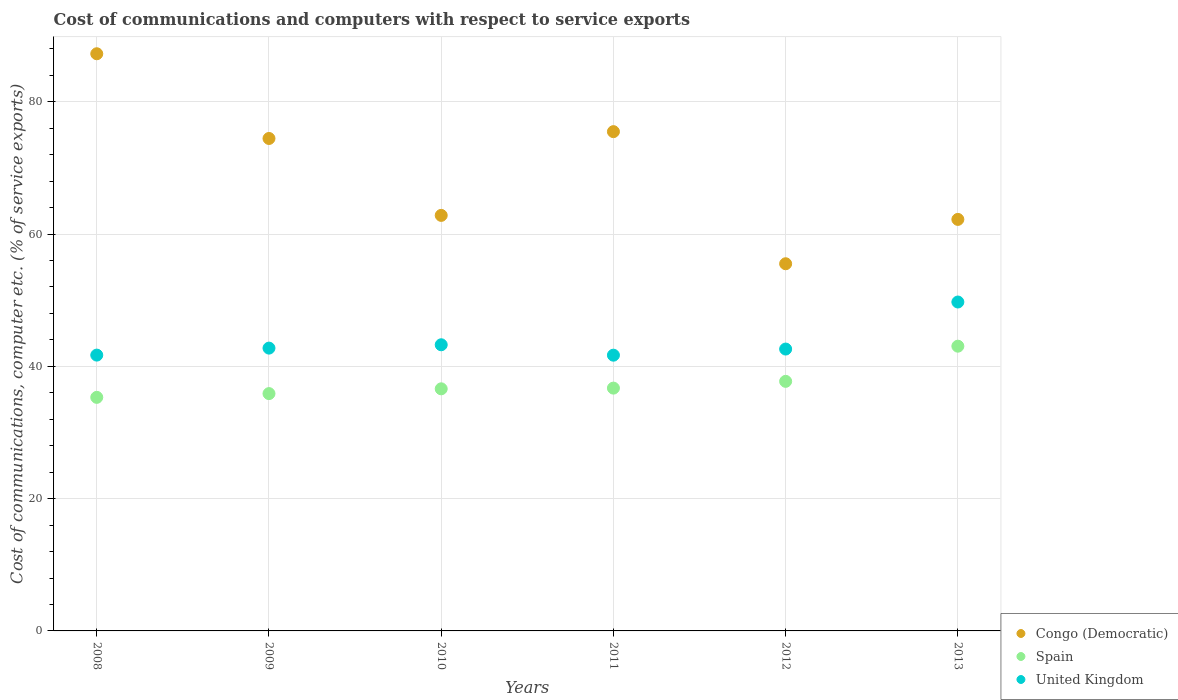How many different coloured dotlines are there?
Offer a very short reply. 3. What is the cost of communications and computers in Congo (Democratic) in 2012?
Give a very brief answer. 55.5. Across all years, what is the maximum cost of communications and computers in United Kingdom?
Make the answer very short. 49.72. Across all years, what is the minimum cost of communications and computers in Congo (Democratic)?
Offer a very short reply. 55.5. In which year was the cost of communications and computers in United Kingdom maximum?
Your response must be concise. 2013. In which year was the cost of communications and computers in Spain minimum?
Your answer should be compact. 2008. What is the total cost of communications and computers in Congo (Democratic) in the graph?
Ensure brevity in your answer.  417.7. What is the difference between the cost of communications and computers in United Kingdom in 2010 and that in 2011?
Your answer should be very brief. 1.57. What is the difference between the cost of communications and computers in Spain in 2011 and the cost of communications and computers in United Kingdom in 2013?
Keep it short and to the point. -13.02. What is the average cost of communications and computers in Congo (Democratic) per year?
Make the answer very short. 69.62. In the year 2012, what is the difference between the cost of communications and computers in United Kingdom and cost of communications and computers in Spain?
Provide a succinct answer. 4.88. In how many years, is the cost of communications and computers in United Kingdom greater than 24 %?
Provide a short and direct response. 6. What is the ratio of the cost of communications and computers in Congo (Democratic) in 2011 to that in 2013?
Provide a succinct answer. 1.21. Is the cost of communications and computers in United Kingdom in 2011 less than that in 2012?
Your answer should be compact. Yes. Is the difference between the cost of communications and computers in United Kingdom in 2008 and 2009 greater than the difference between the cost of communications and computers in Spain in 2008 and 2009?
Make the answer very short. No. What is the difference between the highest and the second highest cost of communications and computers in United Kingdom?
Provide a short and direct response. 6.46. What is the difference between the highest and the lowest cost of communications and computers in United Kingdom?
Provide a short and direct response. 8.04. In how many years, is the cost of communications and computers in United Kingdom greater than the average cost of communications and computers in United Kingdom taken over all years?
Your answer should be compact. 1. Is it the case that in every year, the sum of the cost of communications and computers in United Kingdom and cost of communications and computers in Spain  is greater than the cost of communications and computers in Congo (Democratic)?
Provide a succinct answer. No. Does the cost of communications and computers in United Kingdom monotonically increase over the years?
Keep it short and to the point. No. Is the cost of communications and computers in United Kingdom strictly less than the cost of communications and computers in Spain over the years?
Your response must be concise. No. How many dotlines are there?
Your response must be concise. 3. How many years are there in the graph?
Offer a very short reply. 6. How many legend labels are there?
Keep it short and to the point. 3. What is the title of the graph?
Give a very brief answer. Cost of communications and computers with respect to service exports. What is the label or title of the X-axis?
Ensure brevity in your answer.  Years. What is the label or title of the Y-axis?
Your answer should be very brief. Cost of communications, computer etc. (% of service exports). What is the Cost of communications, computer etc. (% of service exports) in Congo (Democratic) in 2008?
Keep it short and to the point. 87.25. What is the Cost of communications, computer etc. (% of service exports) of Spain in 2008?
Offer a terse response. 35.31. What is the Cost of communications, computer etc. (% of service exports) in United Kingdom in 2008?
Your response must be concise. 41.69. What is the Cost of communications, computer etc. (% of service exports) of Congo (Democratic) in 2009?
Offer a very short reply. 74.44. What is the Cost of communications, computer etc. (% of service exports) of Spain in 2009?
Your response must be concise. 35.88. What is the Cost of communications, computer etc. (% of service exports) in United Kingdom in 2009?
Ensure brevity in your answer.  42.75. What is the Cost of communications, computer etc. (% of service exports) of Congo (Democratic) in 2010?
Offer a terse response. 62.82. What is the Cost of communications, computer etc. (% of service exports) in Spain in 2010?
Provide a succinct answer. 36.6. What is the Cost of communications, computer etc. (% of service exports) in United Kingdom in 2010?
Your answer should be compact. 43.26. What is the Cost of communications, computer etc. (% of service exports) of Congo (Democratic) in 2011?
Provide a short and direct response. 75.48. What is the Cost of communications, computer etc. (% of service exports) in Spain in 2011?
Keep it short and to the point. 36.7. What is the Cost of communications, computer etc. (% of service exports) in United Kingdom in 2011?
Provide a short and direct response. 41.68. What is the Cost of communications, computer etc. (% of service exports) in Congo (Democratic) in 2012?
Your response must be concise. 55.5. What is the Cost of communications, computer etc. (% of service exports) in Spain in 2012?
Keep it short and to the point. 37.73. What is the Cost of communications, computer etc. (% of service exports) of United Kingdom in 2012?
Keep it short and to the point. 42.61. What is the Cost of communications, computer etc. (% of service exports) of Congo (Democratic) in 2013?
Your answer should be very brief. 62.21. What is the Cost of communications, computer etc. (% of service exports) of Spain in 2013?
Ensure brevity in your answer.  43.04. What is the Cost of communications, computer etc. (% of service exports) in United Kingdom in 2013?
Offer a very short reply. 49.72. Across all years, what is the maximum Cost of communications, computer etc. (% of service exports) in Congo (Democratic)?
Your response must be concise. 87.25. Across all years, what is the maximum Cost of communications, computer etc. (% of service exports) of Spain?
Provide a succinct answer. 43.04. Across all years, what is the maximum Cost of communications, computer etc. (% of service exports) of United Kingdom?
Your answer should be compact. 49.72. Across all years, what is the minimum Cost of communications, computer etc. (% of service exports) of Congo (Democratic)?
Your answer should be compact. 55.5. Across all years, what is the minimum Cost of communications, computer etc. (% of service exports) of Spain?
Ensure brevity in your answer.  35.31. Across all years, what is the minimum Cost of communications, computer etc. (% of service exports) in United Kingdom?
Provide a short and direct response. 41.68. What is the total Cost of communications, computer etc. (% of service exports) of Congo (Democratic) in the graph?
Give a very brief answer. 417.7. What is the total Cost of communications, computer etc. (% of service exports) of Spain in the graph?
Offer a terse response. 225.26. What is the total Cost of communications, computer etc. (% of service exports) in United Kingdom in the graph?
Your answer should be compact. 261.72. What is the difference between the Cost of communications, computer etc. (% of service exports) in Congo (Democratic) in 2008 and that in 2009?
Ensure brevity in your answer.  12.81. What is the difference between the Cost of communications, computer etc. (% of service exports) of Spain in 2008 and that in 2009?
Make the answer very short. -0.57. What is the difference between the Cost of communications, computer etc. (% of service exports) in United Kingdom in 2008 and that in 2009?
Your response must be concise. -1.06. What is the difference between the Cost of communications, computer etc. (% of service exports) of Congo (Democratic) in 2008 and that in 2010?
Offer a terse response. 24.43. What is the difference between the Cost of communications, computer etc. (% of service exports) in Spain in 2008 and that in 2010?
Ensure brevity in your answer.  -1.29. What is the difference between the Cost of communications, computer etc. (% of service exports) of United Kingdom in 2008 and that in 2010?
Keep it short and to the point. -1.56. What is the difference between the Cost of communications, computer etc. (% of service exports) in Congo (Democratic) in 2008 and that in 2011?
Ensure brevity in your answer.  11.77. What is the difference between the Cost of communications, computer etc. (% of service exports) in Spain in 2008 and that in 2011?
Offer a very short reply. -1.4. What is the difference between the Cost of communications, computer etc. (% of service exports) in United Kingdom in 2008 and that in 2011?
Ensure brevity in your answer.  0.01. What is the difference between the Cost of communications, computer etc. (% of service exports) in Congo (Democratic) in 2008 and that in 2012?
Keep it short and to the point. 31.74. What is the difference between the Cost of communications, computer etc. (% of service exports) of Spain in 2008 and that in 2012?
Make the answer very short. -2.42. What is the difference between the Cost of communications, computer etc. (% of service exports) of United Kingdom in 2008 and that in 2012?
Your answer should be compact. -0.91. What is the difference between the Cost of communications, computer etc. (% of service exports) in Congo (Democratic) in 2008 and that in 2013?
Give a very brief answer. 25.04. What is the difference between the Cost of communications, computer etc. (% of service exports) of Spain in 2008 and that in 2013?
Your response must be concise. -7.74. What is the difference between the Cost of communications, computer etc. (% of service exports) of United Kingdom in 2008 and that in 2013?
Your answer should be very brief. -8.03. What is the difference between the Cost of communications, computer etc. (% of service exports) of Congo (Democratic) in 2009 and that in 2010?
Ensure brevity in your answer.  11.63. What is the difference between the Cost of communications, computer etc. (% of service exports) in Spain in 2009 and that in 2010?
Keep it short and to the point. -0.72. What is the difference between the Cost of communications, computer etc. (% of service exports) in United Kingdom in 2009 and that in 2010?
Offer a terse response. -0.51. What is the difference between the Cost of communications, computer etc. (% of service exports) in Congo (Democratic) in 2009 and that in 2011?
Make the answer very short. -1.03. What is the difference between the Cost of communications, computer etc. (% of service exports) of Spain in 2009 and that in 2011?
Give a very brief answer. -0.83. What is the difference between the Cost of communications, computer etc. (% of service exports) of United Kingdom in 2009 and that in 2011?
Offer a very short reply. 1.07. What is the difference between the Cost of communications, computer etc. (% of service exports) in Congo (Democratic) in 2009 and that in 2012?
Give a very brief answer. 18.94. What is the difference between the Cost of communications, computer etc. (% of service exports) in Spain in 2009 and that in 2012?
Give a very brief answer. -1.85. What is the difference between the Cost of communications, computer etc. (% of service exports) of United Kingdom in 2009 and that in 2012?
Offer a terse response. 0.14. What is the difference between the Cost of communications, computer etc. (% of service exports) of Congo (Democratic) in 2009 and that in 2013?
Your answer should be very brief. 12.23. What is the difference between the Cost of communications, computer etc. (% of service exports) of Spain in 2009 and that in 2013?
Offer a terse response. -7.17. What is the difference between the Cost of communications, computer etc. (% of service exports) of United Kingdom in 2009 and that in 2013?
Keep it short and to the point. -6.97. What is the difference between the Cost of communications, computer etc. (% of service exports) in Congo (Democratic) in 2010 and that in 2011?
Your answer should be very brief. -12.66. What is the difference between the Cost of communications, computer etc. (% of service exports) in Spain in 2010 and that in 2011?
Provide a succinct answer. -0.11. What is the difference between the Cost of communications, computer etc. (% of service exports) of United Kingdom in 2010 and that in 2011?
Your answer should be very brief. 1.57. What is the difference between the Cost of communications, computer etc. (% of service exports) in Congo (Democratic) in 2010 and that in 2012?
Make the answer very short. 7.31. What is the difference between the Cost of communications, computer etc. (% of service exports) of Spain in 2010 and that in 2012?
Give a very brief answer. -1.13. What is the difference between the Cost of communications, computer etc. (% of service exports) of United Kingdom in 2010 and that in 2012?
Ensure brevity in your answer.  0.65. What is the difference between the Cost of communications, computer etc. (% of service exports) of Congo (Democratic) in 2010 and that in 2013?
Offer a very short reply. 0.61. What is the difference between the Cost of communications, computer etc. (% of service exports) in Spain in 2010 and that in 2013?
Offer a terse response. -6.45. What is the difference between the Cost of communications, computer etc. (% of service exports) of United Kingdom in 2010 and that in 2013?
Offer a very short reply. -6.46. What is the difference between the Cost of communications, computer etc. (% of service exports) of Congo (Democratic) in 2011 and that in 2012?
Keep it short and to the point. 19.97. What is the difference between the Cost of communications, computer etc. (% of service exports) of Spain in 2011 and that in 2012?
Provide a succinct answer. -1.02. What is the difference between the Cost of communications, computer etc. (% of service exports) of United Kingdom in 2011 and that in 2012?
Provide a succinct answer. -0.93. What is the difference between the Cost of communications, computer etc. (% of service exports) in Congo (Democratic) in 2011 and that in 2013?
Your answer should be compact. 13.27. What is the difference between the Cost of communications, computer etc. (% of service exports) of Spain in 2011 and that in 2013?
Provide a short and direct response. -6.34. What is the difference between the Cost of communications, computer etc. (% of service exports) in United Kingdom in 2011 and that in 2013?
Ensure brevity in your answer.  -8.04. What is the difference between the Cost of communications, computer etc. (% of service exports) in Congo (Democratic) in 2012 and that in 2013?
Your answer should be compact. -6.7. What is the difference between the Cost of communications, computer etc. (% of service exports) in Spain in 2012 and that in 2013?
Your answer should be very brief. -5.32. What is the difference between the Cost of communications, computer etc. (% of service exports) in United Kingdom in 2012 and that in 2013?
Make the answer very short. -7.11. What is the difference between the Cost of communications, computer etc. (% of service exports) of Congo (Democratic) in 2008 and the Cost of communications, computer etc. (% of service exports) of Spain in 2009?
Keep it short and to the point. 51.37. What is the difference between the Cost of communications, computer etc. (% of service exports) of Congo (Democratic) in 2008 and the Cost of communications, computer etc. (% of service exports) of United Kingdom in 2009?
Offer a terse response. 44.5. What is the difference between the Cost of communications, computer etc. (% of service exports) in Spain in 2008 and the Cost of communications, computer etc. (% of service exports) in United Kingdom in 2009?
Provide a short and direct response. -7.44. What is the difference between the Cost of communications, computer etc. (% of service exports) in Congo (Democratic) in 2008 and the Cost of communications, computer etc. (% of service exports) in Spain in 2010?
Offer a terse response. 50.65. What is the difference between the Cost of communications, computer etc. (% of service exports) of Congo (Democratic) in 2008 and the Cost of communications, computer etc. (% of service exports) of United Kingdom in 2010?
Make the answer very short. 43.99. What is the difference between the Cost of communications, computer etc. (% of service exports) of Spain in 2008 and the Cost of communications, computer etc. (% of service exports) of United Kingdom in 2010?
Offer a very short reply. -7.95. What is the difference between the Cost of communications, computer etc. (% of service exports) of Congo (Democratic) in 2008 and the Cost of communications, computer etc. (% of service exports) of Spain in 2011?
Keep it short and to the point. 50.55. What is the difference between the Cost of communications, computer etc. (% of service exports) in Congo (Democratic) in 2008 and the Cost of communications, computer etc. (% of service exports) in United Kingdom in 2011?
Offer a terse response. 45.57. What is the difference between the Cost of communications, computer etc. (% of service exports) in Spain in 2008 and the Cost of communications, computer etc. (% of service exports) in United Kingdom in 2011?
Offer a terse response. -6.38. What is the difference between the Cost of communications, computer etc. (% of service exports) of Congo (Democratic) in 2008 and the Cost of communications, computer etc. (% of service exports) of Spain in 2012?
Provide a short and direct response. 49.52. What is the difference between the Cost of communications, computer etc. (% of service exports) in Congo (Democratic) in 2008 and the Cost of communications, computer etc. (% of service exports) in United Kingdom in 2012?
Your response must be concise. 44.64. What is the difference between the Cost of communications, computer etc. (% of service exports) in Spain in 2008 and the Cost of communications, computer etc. (% of service exports) in United Kingdom in 2012?
Make the answer very short. -7.3. What is the difference between the Cost of communications, computer etc. (% of service exports) of Congo (Democratic) in 2008 and the Cost of communications, computer etc. (% of service exports) of Spain in 2013?
Provide a short and direct response. 44.21. What is the difference between the Cost of communications, computer etc. (% of service exports) of Congo (Democratic) in 2008 and the Cost of communications, computer etc. (% of service exports) of United Kingdom in 2013?
Your answer should be compact. 37.53. What is the difference between the Cost of communications, computer etc. (% of service exports) of Spain in 2008 and the Cost of communications, computer etc. (% of service exports) of United Kingdom in 2013?
Offer a terse response. -14.41. What is the difference between the Cost of communications, computer etc. (% of service exports) of Congo (Democratic) in 2009 and the Cost of communications, computer etc. (% of service exports) of Spain in 2010?
Ensure brevity in your answer.  37.84. What is the difference between the Cost of communications, computer etc. (% of service exports) of Congo (Democratic) in 2009 and the Cost of communications, computer etc. (% of service exports) of United Kingdom in 2010?
Your answer should be very brief. 31.19. What is the difference between the Cost of communications, computer etc. (% of service exports) in Spain in 2009 and the Cost of communications, computer etc. (% of service exports) in United Kingdom in 2010?
Make the answer very short. -7.38. What is the difference between the Cost of communications, computer etc. (% of service exports) in Congo (Democratic) in 2009 and the Cost of communications, computer etc. (% of service exports) in Spain in 2011?
Provide a succinct answer. 37.74. What is the difference between the Cost of communications, computer etc. (% of service exports) of Congo (Democratic) in 2009 and the Cost of communications, computer etc. (% of service exports) of United Kingdom in 2011?
Provide a short and direct response. 32.76. What is the difference between the Cost of communications, computer etc. (% of service exports) in Spain in 2009 and the Cost of communications, computer etc. (% of service exports) in United Kingdom in 2011?
Your answer should be compact. -5.81. What is the difference between the Cost of communications, computer etc. (% of service exports) of Congo (Democratic) in 2009 and the Cost of communications, computer etc. (% of service exports) of Spain in 2012?
Give a very brief answer. 36.72. What is the difference between the Cost of communications, computer etc. (% of service exports) in Congo (Democratic) in 2009 and the Cost of communications, computer etc. (% of service exports) in United Kingdom in 2012?
Give a very brief answer. 31.83. What is the difference between the Cost of communications, computer etc. (% of service exports) of Spain in 2009 and the Cost of communications, computer etc. (% of service exports) of United Kingdom in 2012?
Give a very brief answer. -6.73. What is the difference between the Cost of communications, computer etc. (% of service exports) of Congo (Democratic) in 2009 and the Cost of communications, computer etc. (% of service exports) of Spain in 2013?
Provide a short and direct response. 31.4. What is the difference between the Cost of communications, computer etc. (% of service exports) in Congo (Democratic) in 2009 and the Cost of communications, computer etc. (% of service exports) in United Kingdom in 2013?
Give a very brief answer. 24.72. What is the difference between the Cost of communications, computer etc. (% of service exports) in Spain in 2009 and the Cost of communications, computer etc. (% of service exports) in United Kingdom in 2013?
Your response must be concise. -13.84. What is the difference between the Cost of communications, computer etc. (% of service exports) of Congo (Democratic) in 2010 and the Cost of communications, computer etc. (% of service exports) of Spain in 2011?
Offer a very short reply. 26.11. What is the difference between the Cost of communications, computer etc. (% of service exports) in Congo (Democratic) in 2010 and the Cost of communications, computer etc. (% of service exports) in United Kingdom in 2011?
Your answer should be very brief. 21.13. What is the difference between the Cost of communications, computer etc. (% of service exports) in Spain in 2010 and the Cost of communications, computer etc. (% of service exports) in United Kingdom in 2011?
Offer a very short reply. -5.09. What is the difference between the Cost of communications, computer etc. (% of service exports) in Congo (Democratic) in 2010 and the Cost of communications, computer etc. (% of service exports) in Spain in 2012?
Keep it short and to the point. 25.09. What is the difference between the Cost of communications, computer etc. (% of service exports) of Congo (Democratic) in 2010 and the Cost of communications, computer etc. (% of service exports) of United Kingdom in 2012?
Provide a succinct answer. 20.21. What is the difference between the Cost of communications, computer etc. (% of service exports) in Spain in 2010 and the Cost of communications, computer etc. (% of service exports) in United Kingdom in 2012?
Your response must be concise. -6.01. What is the difference between the Cost of communications, computer etc. (% of service exports) in Congo (Democratic) in 2010 and the Cost of communications, computer etc. (% of service exports) in Spain in 2013?
Give a very brief answer. 19.77. What is the difference between the Cost of communications, computer etc. (% of service exports) in Congo (Democratic) in 2010 and the Cost of communications, computer etc. (% of service exports) in United Kingdom in 2013?
Offer a terse response. 13.09. What is the difference between the Cost of communications, computer etc. (% of service exports) in Spain in 2010 and the Cost of communications, computer etc. (% of service exports) in United Kingdom in 2013?
Your answer should be compact. -13.12. What is the difference between the Cost of communications, computer etc. (% of service exports) in Congo (Democratic) in 2011 and the Cost of communications, computer etc. (% of service exports) in Spain in 2012?
Your response must be concise. 37.75. What is the difference between the Cost of communications, computer etc. (% of service exports) of Congo (Democratic) in 2011 and the Cost of communications, computer etc. (% of service exports) of United Kingdom in 2012?
Keep it short and to the point. 32.87. What is the difference between the Cost of communications, computer etc. (% of service exports) in Spain in 2011 and the Cost of communications, computer etc. (% of service exports) in United Kingdom in 2012?
Provide a succinct answer. -5.91. What is the difference between the Cost of communications, computer etc. (% of service exports) in Congo (Democratic) in 2011 and the Cost of communications, computer etc. (% of service exports) in Spain in 2013?
Offer a terse response. 32.43. What is the difference between the Cost of communications, computer etc. (% of service exports) in Congo (Democratic) in 2011 and the Cost of communications, computer etc. (% of service exports) in United Kingdom in 2013?
Ensure brevity in your answer.  25.75. What is the difference between the Cost of communications, computer etc. (% of service exports) of Spain in 2011 and the Cost of communications, computer etc. (% of service exports) of United Kingdom in 2013?
Offer a terse response. -13.02. What is the difference between the Cost of communications, computer etc. (% of service exports) of Congo (Democratic) in 2012 and the Cost of communications, computer etc. (% of service exports) of Spain in 2013?
Provide a succinct answer. 12.46. What is the difference between the Cost of communications, computer etc. (% of service exports) in Congo (Democratic) in 2012 and the Cost of communications, computer etc. (% of service exports) in United Kingdom in 2013?
Your answer should be very brief. 5.78. What is the difference between the Cost of communications, computer etc. (% of service exports) in Spain in 2012 and the Cost of communications, computer etc. (% of service exports) in United Kingdom in 2013?
Your answer should be compact. -11.99. What is the average Cost of communications, computer etc. (% of service exports) of Congo (Democratic) per year?
Provide a succinct answer. 69.62. What is the average Cost of communications, computer etc. (% of service exports) of Spain per year?
Provide a succinct answer. 37.54. What is the average Cost of communications, computer etc. (% of service exports) of United Kingdom per year?
Offer a very short reply. 43.62. In the year 2008, what is the difference between the Cost of communications, computer etc. (% of service exports) of Congo (Democratic) and Cost of communications, computer etc. (% of service exports) of Spain?
Provide a short and direct response. 51.94. In the year 2008, what is the difference between the Cost of communications, computer etc. (% of service exports) in Congo (Democratic) and Cost of communications, computer etc. (% of service exports) in United Kingdom?
Your answer should be very brief. 45.55. In the year 2008, what is the difference between the Cost of communications, computer etc. (% of service exports) of Spain and Cost of communications, computer etc. (% of service exports) of United Kingdom?
Your answer should be compact. -6.39. In the year 2009, what is the difference between the Cost of communications, computer etc. (% of service exports) in Congo (Democratic) and Cost of communications, computer etc. (% of service exports) in Spain?
Keep it short and to the point. 38.57. In the year 2009, what is the difference between the Cost of communications, computer etc. (% of service exports) of Congo (Democratic) and Cost of communications, computer etc. (% of service exports) of United Kingdom?
Provide a short and direct response. 31.69. In the year 2009, what is the difference between the Cost of communications, computer etc. (% of service exports) in Spain and Cost of communications, computer etc. (% of service exports) in United Kingdom?
Your response must be concise. -6.88. In the year 2010, what is the difference between the Cost of communications, computer etc. (% of service exports) of Congo (Democratic) and Cost of communications, computer etc. (% of service exports) of Spain?
Make the answer very short. 26.22. In the year 2010, what is the difference between the Cost of communications, computer etc. (% of service exports) of Congo (Democratic) and Cost of communications, computer etc. (% of service exports) of United Kingdom?
Your response must be concise. 19.56. In the year 2010, what is the difference between the Cost of communications, computer etc. (% of service exports) of Spain and Cost of communications, computer etc. (% of service exports) of United Kingdom?
Keep it short and to the point. -6.66. In the year 2011, what is the difference between the Cost of communications, computer etc. (% of service exports) of Congo (Democratic) and Cost of communications, computer etc. (% of service exports) of Spain?
Give a very brief answer. 38.77. In the year 2011, what is the difference between the Cost of communications, computer etc. (% of service exports) in Congo (Democratic) and Cost of communications, computer etc. (% of service exports) in United Kingdom?
Provide a short and direct response. 33.79. In the year 2011, what is the difference between the Cost of communications, computer etc. (% of service exports) in Spain and Cost of communications, computer etc. (% of service exports) in United Kingdom?
Your answer should be very brief. -4.98. In the year 2012, what is the difference between the Cost of communications, computer etc. (% of service exports) of Congo (Democratic) and Cost of communications, computer etc. (% of service exports) of Spain?
Provide a short and direct response. 17.78. In the year 2012, what is the difference between the Cost of communications, computer etc. (% of service exports) in Congo (Democratic) and Cost of communications, computer etc. (% of service exports) in United Kingdom?
Keep it short and to the point. 12.9. In the year 2012, what is the difference between the Cost of communications, computer etc. (% of service exports) in Spain and Cost of communications, computer etc. (% of service exports) in United Kingdom?
Give a very brief answer. -4.88. In the year 2013, what is the difference between the Cost of communications, computer etc. (% of service exports) of Congo (Democratic) and Cost of communications, computer etc. (% of service exports) of Spain?
Provide a succinct answer. 19.17. In the year 2013, what is the difference between the Cost of communications, computer etc. (% of service exports) of Congo (Democratic) and Cost of communications, computer etc. (% of service exports) of United Kingdom?
Your answer should be very brief. 12.49. In the year 2013, what is the difference between the Cost of communications, computer etc. (% of service exports) of Spain and Cost of communications, computer etc. (% of service exports) of United Kingdom?
Give a very brief answer. -6.68. What is the ratio of the Cost of communications, computer etc. (% of service exports) of Congo (Democratic) in 2008 to that in 2009?
Your answer should be very brief. 1.17. What is the ratio of the Cost of communications, computer etc. (% of service exports) of Spain in 2008 to that in 2009?
Ensure brevity in your answer.  0.98. What is the ratio of the Cost of communications, computer etc. (% of service exports) in United Kingdom in 2008 to that in 2009?
Your answer should be compact. 0.98. What is the ratio of the Cost of communications, computer etc. (% of service exports) in Congo (Democratic) in 2008 to that in 2010?
Keep it short and to the point. 1.39. What is the ratio of the Cost of communications, computer etc. (% of service exports) of Spain in 2008 to that in 2010?
Your response must be concise. 0.96. What is the ratio of the Cost of communications, computer etc. (% of service exports) of United Kingdom in 2008 to that in 2010?
Offer a very short reply. 0.96. What is the ratio of the Cost of communications, computer etc. (% of service exports) of Congo (Democratic) in 2008 to that in 2011?
Ensure brevity in your answer.  1.16. What is the ratio of the Cost of communications, computer etc. (% of service exports) in Congo (Democratic) in 2008 to that in 2012?
Your answer should be compact. 1.57. What is the ratio of the Cost of communications, computer etc. (% of service exports) of Spain in 2008 to that in 2012?
Make the answer very short. 0.94. What is the ratio of the Cost of communications, computer etc. (% of service exports) in United Kingdom in 2008 to that in 2012?
Make the answer very short. 0.98. What is the ratio of the Cost of communications, computer etc. (% of service exports) in Congo (Democratic) in 2008 to that in 2013?
Give a very brief answer. 1.4. What is the ratio of the Cost of communications, computer etc. (% of service exports) in Spain in 2008 to that in 2013?
Ensure brevity in your answer.  0.82. What is the ratio of the Cost of communications, computer etc. (% of service exports) of United Kingdom in 2008 to that in 2013?
Your answer should be very brief. 0.84. What is the ratio of the Cost of communications, computer etc. (% of service exports) of Congo (Democratic) in 2009 to that in 2010?
Offer a very short reply. 1.19. What is the ratio of the Cost of communications, computer etc. (% of service exports) of Spain in 2009 to that in 2010?
Ensure brevity in your answer.  0.98. What is the ratio of the Cost of communications, computer etc. (% of service exports) of United Kingdom in 2009 to that in 2010?
Keep it short and to the point. 0.99. What is the ratio of the Cost of communications, computer etc. (% of service exports) of Congo (Democratic) in 2009 to that in 2011?
Give a very brief answer. 0.99. What is the ratio of the Cost of communications, computer etc. (% of service exports) of Spain in 2009 to that in 2011?
Give a very brief answer. 0.98. What is the ratio of the Cost of communications, computer etc. (% of service exports) in United Kingdom in 2009 to that in 2011?
Your answer should be very brief. 1.03. What is the ratio of the Cost of communications, computer etc. (% of service exports) of Congo (Democratic) in 2009 to that in 2012?
Make the answer very short. 1.34. What is the ratio of the Cost of communications, computer etc. (% of service exports) in Spain in 2009 to that in 2012?
Your answer should be very brief. 0.95. What is the ratio of the Cost of communications, computer etc. (% of service exports) of United Kingdom in 2009 to that in 2012?
Your response must be concise. 1. What is the ratio of the Cost of communications, computer etc. (% of service exports) of Congo (Democratic) in 2009 to that in 2013?
Your response must be concise. 1.2. What is the ratio of the Cost of communications, computer etc. (% of service exports) in Spain in 2009 to that in 2013?
Offer a terse response. 0.83. What is the ratio of the Cost of communications, computer etc. (% of service exports) in United Kingdom in 2009 to that in 2013?
Your answer should be very brief. 0.86. What is the ratio of the Cost of communications, computer etc. (% of service exports) of Congo (Democratic) in 2010 to that in 2011?
Provide a succinct answer. 0.83. What is the ratio of the Cost of communications, computer etc. (% of service exports) in United Kingdom in 2010 to that in 2011?
Offer a very short reply. 1.04. What is the ratio of the Cost of communications, computer etc. (% of service exports) in Congo (Democratic) in 2010 to that in 2012?
Provide a succinct answer. 1.13. What is the ratio of the Cost of communications, computer etc. (% of service exports) in Spain in 2010 to that in 2012?
Give a very brief answer. 0.97. What is the ratio of the Cost of communications, computer etc. (% of service exports) in United Kingdom in 2010 to that in 2012?
Make the answer very short. 1.02. What is the ratio of the Cost of communications, computer etc. (% of service exports) of Congo (Democratic) in 2010 to that in 2013?
Keep it short and to the point. 1.01. What is the ratio of the Cost of communications, computer etc. (% of service exports) of Spain in 2010 to that in 2013?
Give a very brief answer. 0.85. What is the ratio of the Cost of communications, computer etc. (% of service exports) in United Kingdom in 2010 to that in 2013?
Offer a terse response. 0.87. What is the ratio of the Cost of communications, computer etc. (% of service exports) in Congo (Democratic) in 2011 to that in 2012?
Ensure brevity in your answer.  1.36. What is the ratio of the Cost of communications, computer etc. (% of service exports) in Spain in 2011 to that in 2012?
Make the answer very short. 0.97. What is the ratio of the Cost of communications, computer etc. (% of service exports) in United Kingdom in 2011 to that in 2012?
Make the answer very short. 0.98. What is the ratio of the Cost of communications, computer etc. (% of service exports) of Congo (Democratic) in 2011 to that in 2013?
Keep it short and to the point. 1.21. What is the ratio of the Cost of communications, computer etc. (% of service exports) in Spain in 2011 to that in 2013?
Ensure brevity in your answer.  0.85. What is the ratio of the Cost of communications, computer etc. (% of service exports) in United Kingdom in 2011 to that in 2013?
Ensure brevity in your answer.  0.84. What is the ratio of the Cost of communications, computer etc. (% of service exports) in Congo (Democratic) in 2012 to that in 2013?
Ensure brevity in your answer.  0.89. What is the ratio of the Cost of communications, computer etc. (% of service exports) of Spain in 2012 to that in 2013?
Give a very brief answer. 0.88. What is the ratio of the Cost of communications, computer etc. (% of service exports) in United Kingdom in 2012 to that in 2013?
Make the answer very short. 0.86. What is the difference between the highest and the second highest Cost of communications, computer etc. (% of service exports) of Congo (Democratic)?
Ensure brevity in your answer.  11.77. What is the difference between the highest and the second highest Cost of communications, computer etc. (% of service exports) in Spain?
Your answer should be compact. 5.32. What is the difference between the highest and the second highest Cost of communications, computer etc. (% of service exports) of United Kingdom?
Offer a terse response. 6.46. What is the difference between the highest and the lowest Cost of communications, computer etc. (% of service exports) of Congo (Democratic)?
Your answer should be compact. 31.74. What is the difference between the highest and the lowest Cost of communications, computer etc. (% of service exports) in Spain?
Your response must be concise. 7.74. What is the difference between the highest and the lowest Cost of communications, computer etc. (% of service exports) in United Kingdom?
Provide a short and direct response. 8.04. 